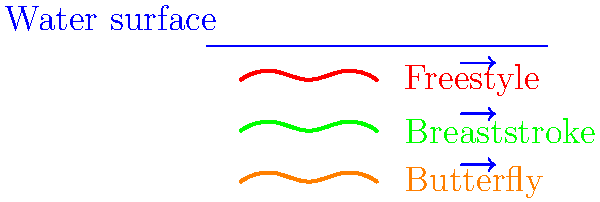Based on the streamline diagrams of swimmers shown above, which swimming stroke is likely to have the least drag and why? How might this information be useful in organizing a science fair project for students? To answer this question, we need to analyze the streamline diagrams for each swimming stroke:

1. Freestyle (Red line):
   - The body position is relatively flat and streamlined.
   - There are small undulations in the line, representing the rotation of the body.

2. Breaststroke (Green line):
   - The line shows more significant up and down movements.
   - This indicates a less streamlined position with more frontal area exposed to water.

3. Butterfly (Orange line):
   - Similar to breaststroke, it shows pronounced up and down movements.
   - This suggests a large amount of frontal area exposed to water during certain phases of the stroke.

Analyzing these diagrams:
- The freestyle stroke appears to have the most streamlined position.
- A more streamlined position reduces the frontal area exposed to water.
- Reduced frontal area leads to less drag force, as drag is proportional to the cross-sectional area perpendicular to the flow.

The drag force in fluid dynamics is given by the equation:

$$F_d = \frac{1}{2} \rho v^2 C_d A$$

Where:
$F_d$ = drag force
$\rho$ = fluid density
$v$ = velocity of the object relative to the fluid
$C_d$ = drag coefficient
$A$ = cross-sectional area

The freestyle stroke minimizes $A$, thereby reducing the drag force.

For a science fair project, students could:
1. Create models of swimmers in different stroke positions.
2. Test these models in a water flow tank or wind tunnel.
3. Measure and compare the drag forces experienced by each model.
4. Analyze how small changes in body position affect drag.
5. Propose improvements to swimming techniques based on their findings.

This project would combine principles of fluid dynamics, biomechanics, and sports science, making it an excellent interdisciplinary learning opportunity.
Answer: Freestyle; lowest frontal area exposed to water flow. 